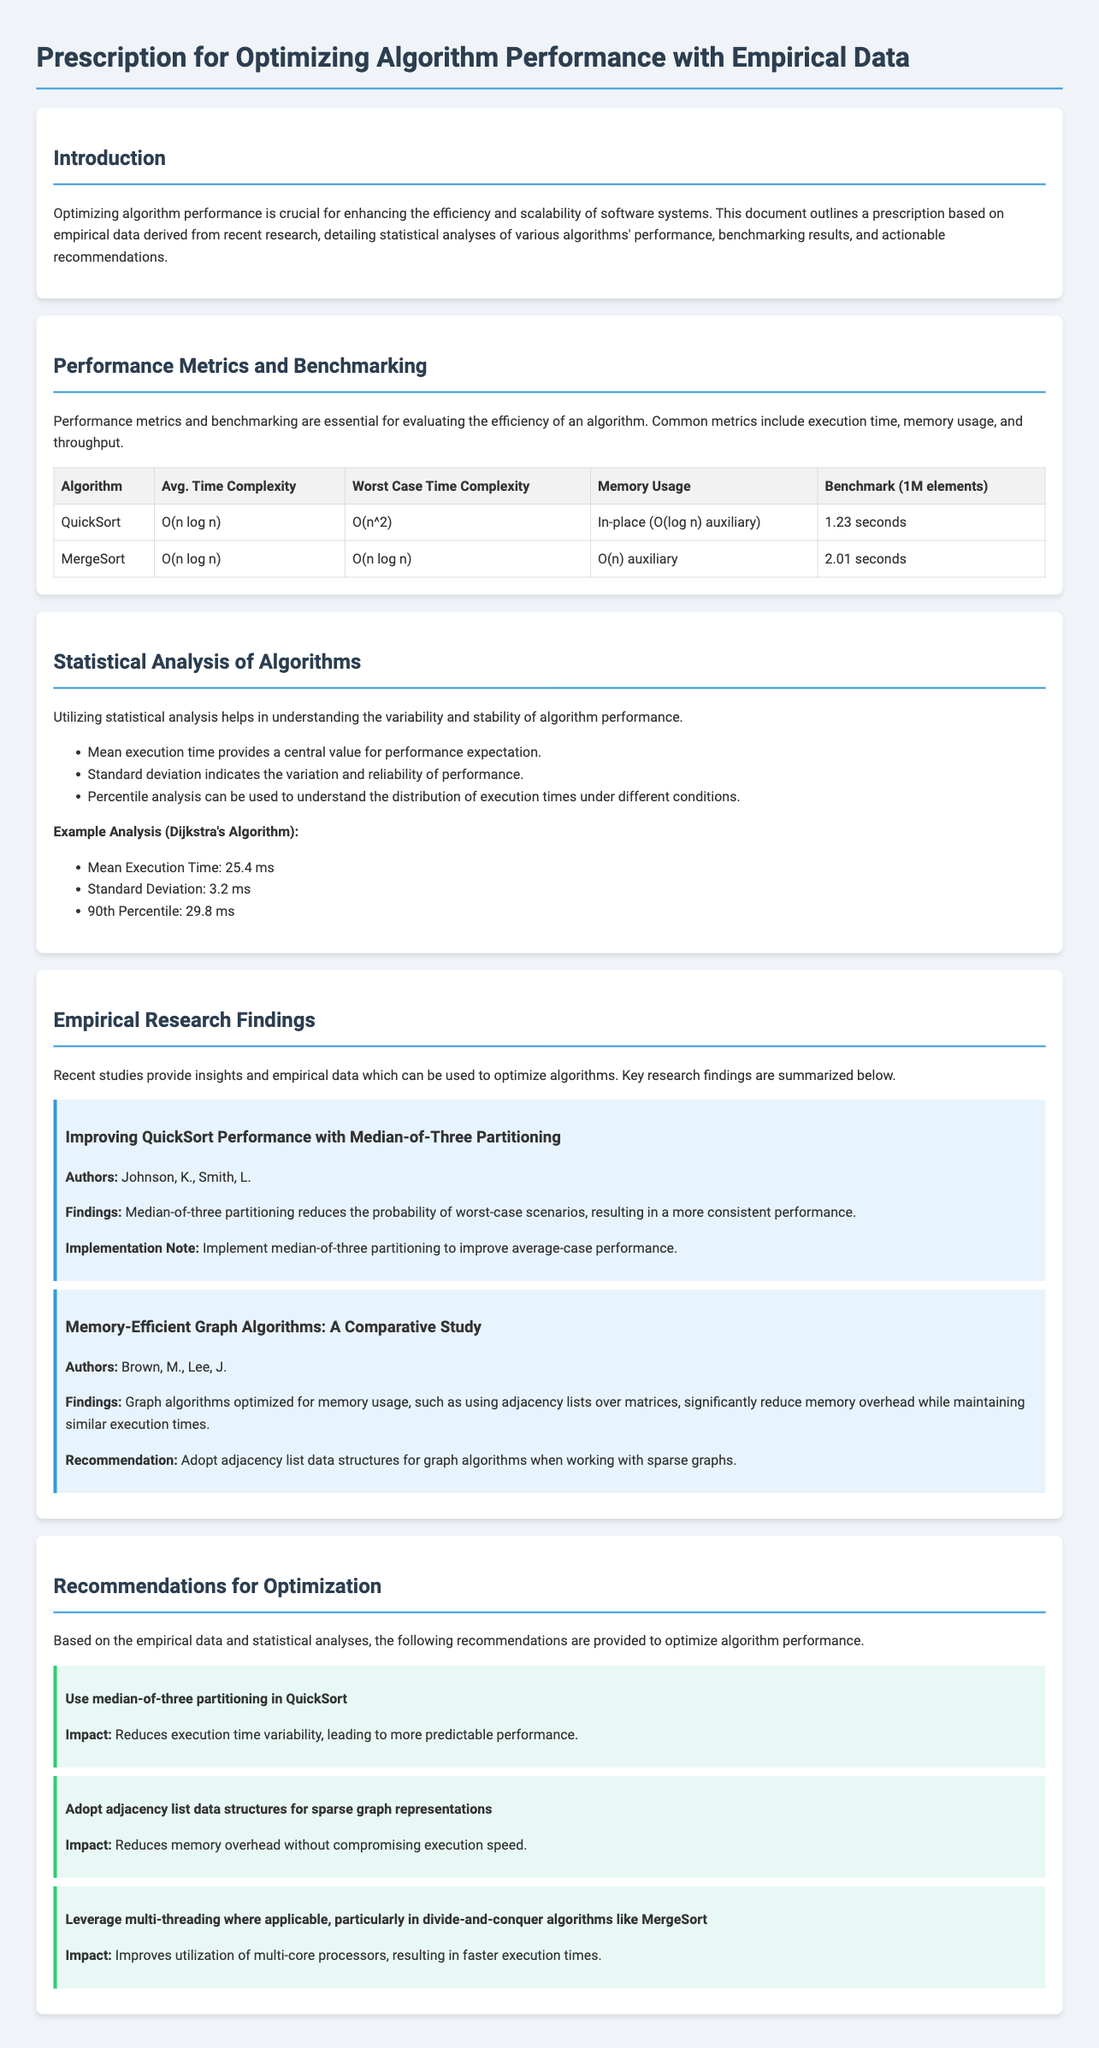What is the title of the document? The title of the document indicates its primary focus on optimizing algorithm performance with empirical data.
Answer: Prescription for Optimizing Algorithm Performance with Empirical Data What is the average time complexity of QuickSort? The average time complexity is a crucial performance metric that indicates algorithm efficiency under typical conditions.
Answer: O(n log n) Who are the authors of the study on improving QuickSort performance? Author names provide credibility to the findings and insights about the specific algorithm's optimization.
Answer: Johnson, K., Smith, L What is the memory usage characteristic of MergeSort? Memory usage is an important metric in understanding an algorithm's resource efficiency.
Answer: O(n) auxiliary What is the mean execution time of Dijkstra's Algorithm? The mean execution time reflects the average performance expectation under testing conditions.
Answer: 25.4 ms What optimization is recommended for sparse graph representations? This recommendation focuses on data structure selection to improve algorithm performance in specific scenarios.
Answer: Adjacency list data structures What is the impact of using median-of-three partitioning in QuickSort? Understanding the impact of recommendations is vital for assessing their effectiveness on performance.
Answer: Reduces execution time variability How does leveraging multi-threading benefit MergeSort? This question examines the advantages of applying modern computing techniques to algorithm performance.
Answer: Improves utilization of multi-core processors 